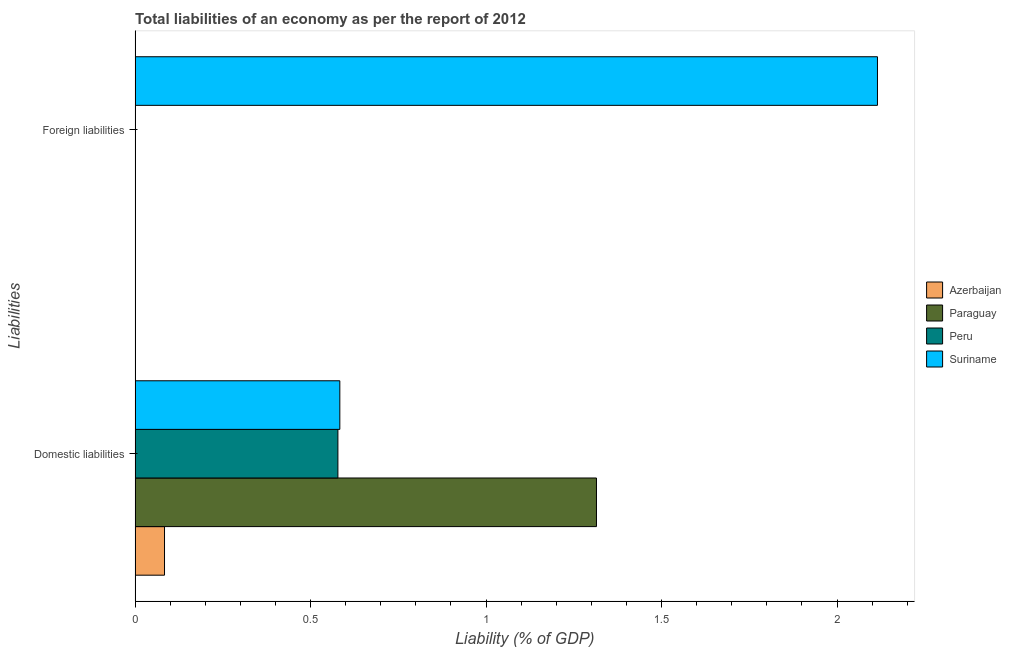Are the number of bars per tick equal to the number of legend labels?
Offer a very short reply. No. How many bars are there on the 2nd tick from the bottom?
Offer a very short reply. 1. What is the label of the 2nd group of bars from the top?
Offer a very short reply. Domestic liabilities. Across all countries, what is the maximum incurrence of foreign liabilities?
Provide a short and direct response. 2.12. In which country was the incurrence of domestic liabilities maximum?
Ensure brevity in your answer.  Paraguay. What is the total incurrence of foreign liabilities in the graph?
Your answer should be compact. 2.12. What is the difference between the incurrence of domestic liabilities in Peru and that in Azerbaijan?
Keep it short and to the point. 0.49. What is the difference between the incurrence of foreign liabilities in Paraguay and the incurrence of domestic liabilities in Suriname?
Keep it short and to the point. -0.58. What is the average incurrence of domestic liabilities per country?
Give a very brief answer. 0.64. What is the difference between the incurrence of domestic liabilities and incurrence of foreign liabilities in Suriname?
Keep it short and to the point. -1.53. What is the ratio of the incurrence of domestic liabilities in Azerbaijan to that in Peru?
Your answer should be very brief. 0.15. Is the incurrence of domestic liabilities in Paraguay less than that in Suriname?
Make the answer very short. No. In how many countries, is the incurrence of domestic liabilities greater than the average incurrence of domestic liabilities taken over all countries?
Your response must be concise. 1. Are all the bars in the graph horizontal?
Give a very brief answer. Yes. How many countries are there in the graph?
Your response must be concise. 4. What is the difference between two consecutive major ticks on the X-axis?
Provide a short and direct response. 0.5. Does the graph contain grids?
Provide a succinct answer. No. How are the legend labels stacked?
Offer a very short reply. Vertical. What is the title of the graph?
Your answer should be very brief. Total liabilities of an economy as per the report of 2012. Does "Belarus" appear as one of the legend labels in the graph?
Provide a short and direct response. No. What is the label or title of the X-axis?
Ensure brevity in your answer.  Liability (% of GDP). What is the label or title of the Y-axis?
Offer a terse response. Liabilities. What is the Liability (% of GDP) in Azerbaijan in Domestic liabilities?
Offer a terse response. 0.08. What is the Liability (% of GDP) of Paraguay in Domestic liabilities?
Offer a very short reply. 1.31. What is the Liability (% of GDP) in Peru in Domestic liabilities?
Keep it short and to the point. 0.58. What is the Liability (% of GDP) of Suriname in Domestic liabilities?
Offer a very short reply. 0.58. What is the Liability (% of GDP) of Peru in Foreign liabilities?
Offer a terse response. 0. What is the Liability (% of GDP) of Suriname in Foreign liabilities?
Provide a short and direct response. 2.12. Across all Liabilities, what is the maximum Liability (% of GDP) of Azerbaijan?
Your response must be concise. 0.08. Across all Liabilities, what is the maximum Liability (% of GDP) in Paraguay?
Make the answer very short. 1.31. Across all Liabilities, what is the maximum Liability (% of GDP) of Peru?
Make the answer very short. 0.58. Across all Liabilities, what is the maximum Liability (% of GDP) in Suriname?
Your response must be concise. 2.12. Across all Liabilities, what is the minimum Liability (% of GDP) in Peru?
Keep it short and to the point. 0. Across all Liabilities, what is the minimum Liability (% of GDP) of Suriname?
Offer a terse response. 0.58. What is the total Liability (% of GDP) of Azerbaijan in the graph?
Make the answer very short. 0.08. What is the total Liability (% of GDP) in Paraguay in the graph?
Your answer should be compact. 1.31. What is the total Liability (% of GDP) in Peru in the graph?
Ensure brevity in your answer.  0.58. What is the total Liability (% of GDP) of Suriname in the graph?
Keep it short and to the point. 2.7. What is the difference between the Liability (% of GDP) of Suriname in Domestic liabilities and that in Foreign liabilities?
Keep it short and to the point. -1.53. What is the difference between the Liability (% of GDP) of Azerbaijan in Domestic liabilities and the Liability (% of GDP) of Suriname in Foreign liabilities?
Ensure brevity in your answer.  -2.03. What is the difference between the Liability (% of GDP) of Paraguay in Domestic liabilities and the Liability (% of GDP) of Suriname in Foreign liabilities?
Your response must be concise. -0.8. What is the difference between the Liability (% of GDP) of Peru in Domestic liabilities and the Liability (% of GDP) of Suriname in Foreign liabilities?
Give a very brief answer. -1.54. What is the average Liability (% of GDP) of Azerbaijan per Liabilities?
Offer a terse response. 0.04. What is the average Liability (% of GDP) in Paraguay per Liabilities?
Offer a terse response. 0.66. What is the average Liability (% of GDP) in Peru per Liabilities?
Offer a very short reply. 0.29. What is the average Liability (% of GDP) in Suriname per Liabilities?
Your answer should be compact. 1.35. What is the difference between the Liability (% of GDP) of Azerbaijan and Liability (% of GDP) of Paraguay in Domestic liabilities?
Your answer should be compact. -1.23. What is the difference between the Liability (% of GDP) of Azerbaijan and Liability (% of GDP) of Peru in Domestic liabilities?
Provide a short and direct response. -0.49. What is the difference between the Liability (% of GDP) of Azerbaijan and Liability (% of GDP) of Suriname in Domestic liabilities?
Offer a very short reply. -0.5. What is the difference between the Liability (% of GDP) in Paraguay and Liability (% of GDP) in Peru in Domestic liabilities?
Provide a succinct answer. 0.74. What is the difference between the Liability (% of GDP) in Paraguay and Liability (% of GDP) in Suriname in Domestic liabilities?
Your response must be concise. 0.73. What is the difference between the Liability (% of GDP) of Peru and Liability (% of GDP) of Suriname in Domestic liabilities?
Your response must be concise. -0.01. What is the ratio of the Liability (% of GDP) in Suriname in Domestic liabilities to that in Foreign liabilities?
Make the answer very short. 0.28. What is the difference between the highest and the second highest Liability (% of GDP) of Suriname?
Your response must be concise. 1.53. What is the difference between the highest and the lowest Liability (% of GDP) of Azerbaijan?
Offer a terse response. 0.08. What is the difference between the highest and the lowest Liability (% of GDP) in Paraguay?
Keep it short and to the point. 1.31. What is the difference between the highest and the lowest Liability (% of GDP) in Peru?
Make the answer very short. 0.58. What is the difference between the highest and the lowest Liability (% of GDP) of Suriname?
Provide a succinct answer. 1.53. 